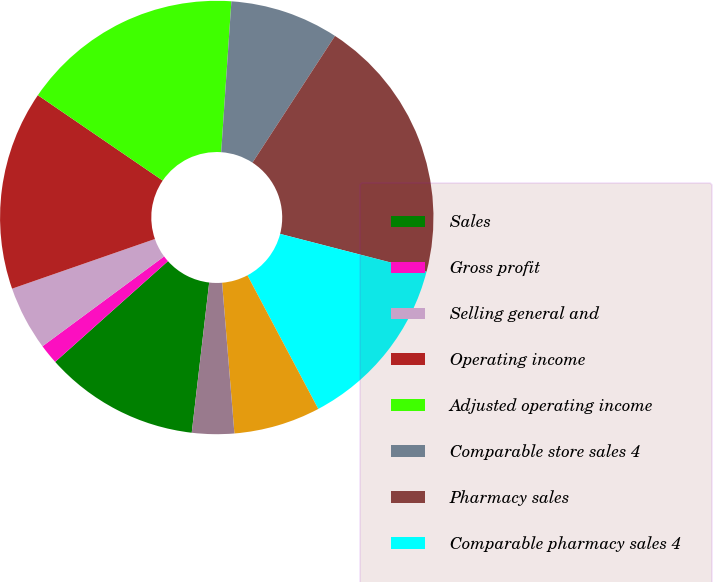Convert chart. <chart><loc_0><loc_0><loc_500><loc_500><pie_chart><fcel>Sales<fcel>Gross profit<fcel>Selling general and<fcel>Operating income<fcel>Adjusted operating income<fcel>Comparable store sales 4<fcel>Pharmacy sales<fcel>Comparable pharmacy sales 4<fcel>Retail sales<fcel>Comparable retail sales 4<nl><fcel>11.55%<fcel>1.48%<fcel>4.8%<fcel>14.87%<fcel>16.53%<fcel>8.11%<fcel>19.84%<fcel>13.21%<fcel>6.46%<fcel>3.14%<nl></chart> 